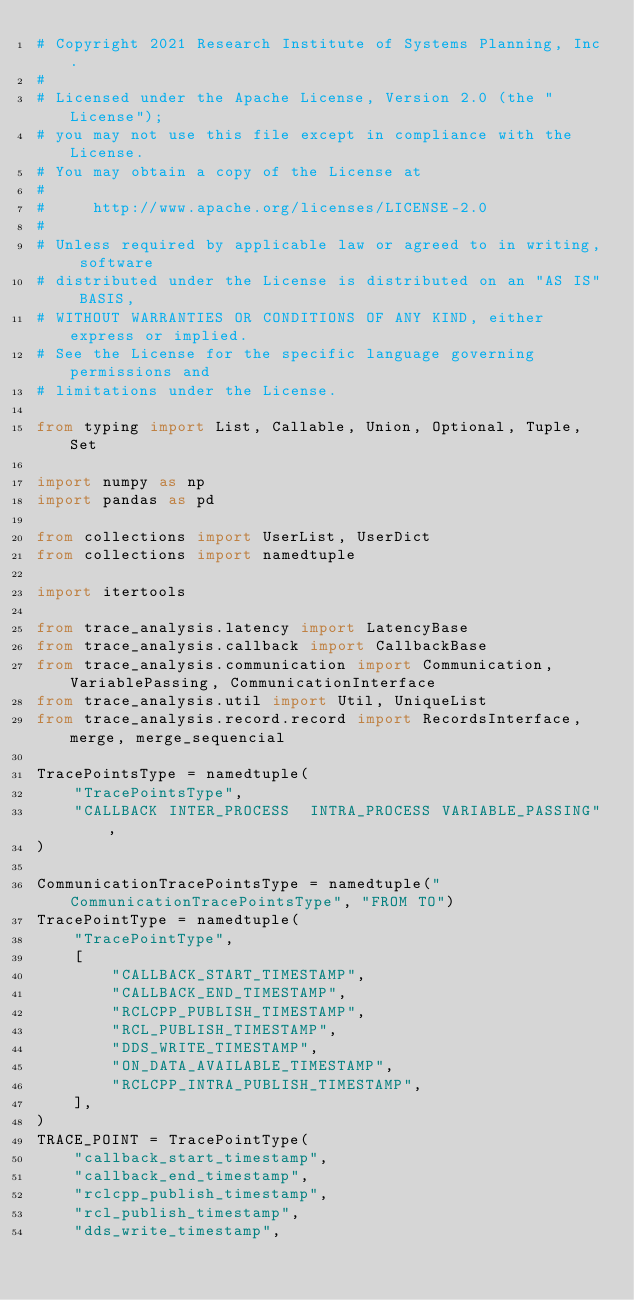Convert code to text. <code><loc_0><loc_0><loc_500><loc_500><_Python_># Copyright 2021 Research Institute of Systems Planning, Inc.
#
# Licensed under the Apache License, Version 2.0 (the "License");
# you may not use this file except in compliance with the License.
# You may obtain a copy of the License at
#
#     http://www.apache.org/licenses/LICENSE-2.0
#
# Unless required by applicable law or agreed to in writing, software
# distributed under the License is distributed on an "AS IS" BASIS,
# WITHOUT WARRANTIES OR CONDITIONS OF ANY KIND, either express or implied.
# See the License for the specific language governing permissions and
# limitations under the License.

from typing import List, Callable, Union, Optional, Tuple, Set

import numpy as np
import pandas as pd

from collections import UserList, UserDict
from collections import namedtuple

import itertools

from trace_analysis.latency import LatencyBase
from trace_analysis.callback import CallbackBase
from trace_analysis.communication import Communication, VariablePassing, CommunicationInterface
from trace_analysis.util import Util, UniqueList
from trace_analysis.record.record import RecordsInterface, merge, merge_sequencial

TracePointsType = namedtuple(
    "TracePointsType",
    "CALLBACK INTER_PROCESS  INTRA_PROCESS VARIABLE_PASSING",
)

CommunicationTracePointsType = namedtuple("CommunicationTracePointsType", "FROM TO")
TracePointType = namedtuple(
    "TracePointType",
    [
        "CALLBACK_START_TIMESTAMP",
        "CALLBACK_END_TIMESTAMP",
        "RCLCPP_PUBLISH_TIMESTAMP",
        "RCL_PUBLISH_TIMESTAMP",
        "DDS_WRITE_TIMESTAMP",
        "ON_DATA_AVAILABLE_TIMESTAMP",
        "RCLCPP_INTRA_PUBLISH_TIMESTAMP",
    ],
)
TRACE_POINT = TracePointType(
    "callback_start_timestamp",
    "callback_end_timestamp",
    "rclcpp_publish_timestamp",
    "rcl_publish_timestamp",
    "dds_write_timestamp",</code> 